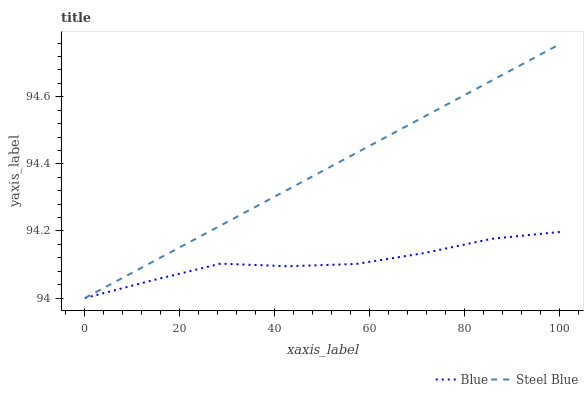Does Blue have the minimum area under the curve?
Answer yes or no. Yes. Does Steel Blue have the maximum area under the curve?
Answer yes or no. Yes. Does Steel Blue have the minimum area under the curve?
Answer yes or no. No. Is Steel Blue the smoothest?
Answer yes or no. Yes. Is Blue the roughest?
Answer yes or no. Yes. Is Steel Blue the roughest?
Answer yes or no. No. Does Blue have the lowest value?
Answer yes or no. Yes. Does Steel Blue have the highest value?
Answer yes or no. Yes. Does Blue intersect Steel Blue?
Answer yes or no. Yes. Is Blue less than Steel Blue?
Answer yes or no. No. Is Blue greater than Steel Blue?
Answer yes or no. No. 